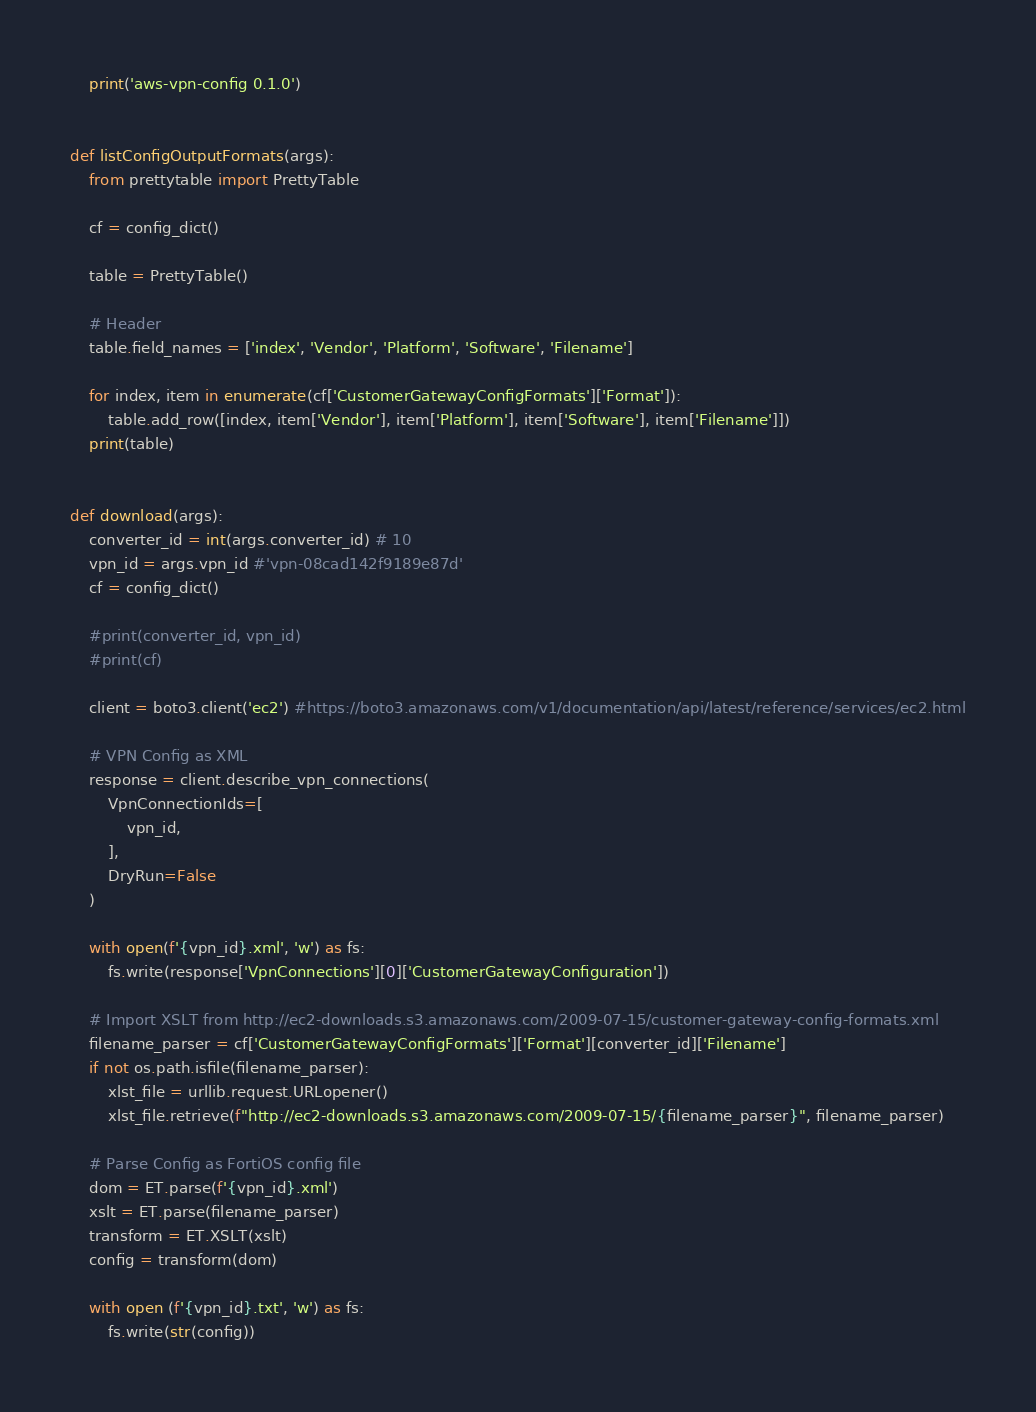Convert code to text. <code><loc_0><loc_0><loc_500><loc_500><_Python_>    print('aws-vpn-config 0.1.0')


def listConfigOutputFormats(args):
    from prettytable import PrettyTable

    cf = config_dict()
    
    table = PrettyTable()

    # Header
    table.field_names = ['index', 'Vendor', 'Platform', 'Software', 'Filename']
    
    for index, item in enumerate(cf['CustomerGatewayConfigFormats']['Format']):
        table.add_row([index, item['Vendor'], item['Platform'], item['Software'], item['Filename']])
    print(table)


def download(args):
    converter_id = int(args.converter_id) # 10
    vpn_id = args.vpn_id #'vpn-08cad142f9189e87d'
    cf = config_dict()

    #print(converter_id, vpn_id)
    #print(cf)

    client = boto3.client('ec2') #https://boto3.amazonaws.com/v1/documentation/api/latest/reference/services/ec2.html

    # VPN Config as XML
    response = client.describe_vpn_connections(
        VpnConnectionIds=[
            vpn_id,
        ],
        DryRun=False
    )

    with open(f'{vpn_id}.xml', 'w') as fs:
        fs.write(response['VpnConnections'][0]['CustomerGatewayConfiguration'])

    # Import XSLT from http://ec2-downloads.s3.amazonaws.com/2009-07-15/customer-gateway-config-formats.xml
    filename_parser = cf['CustomerGatewayConfigFormats']['Format'][converter_id]['Filename']
    if not os.path.isfile(filename_parser):
        xlst_file = urllib.request.URLopener()
        xlst_file.retrieve(f"http://ec2-downloads.s3.amazonaws.com/2009-07-15/{filename_parser}", filename_parser)

    # Parse Config as FortiOS config file
    dom = ET.parse(f'{vpn_id}.xml')
    xslt = ET.parse(filename_parser)
    transform = ET.XSLT(xslt)
    config = transform(dom)

    with open (f'{vpn_id}.txt', 'w') as fs:
        fs.write(str(config))
</code> 